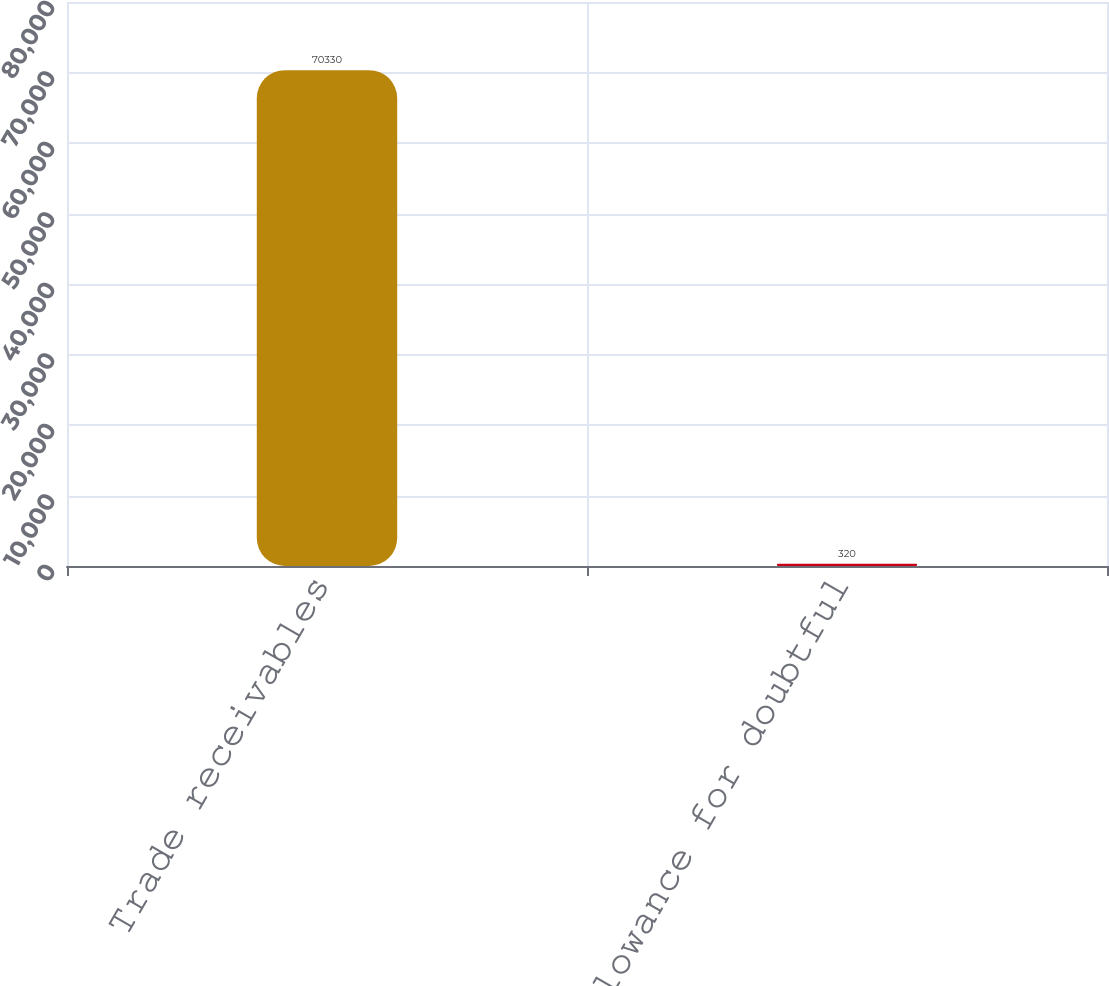Convert chart. <chart><loc_0><loc_0><loc_500><loc_500><bar_chart><fcel>Trade receivables<fcel>Allowance for doubtful<nl><fcel>70330<fcel>320<nl></chart> 